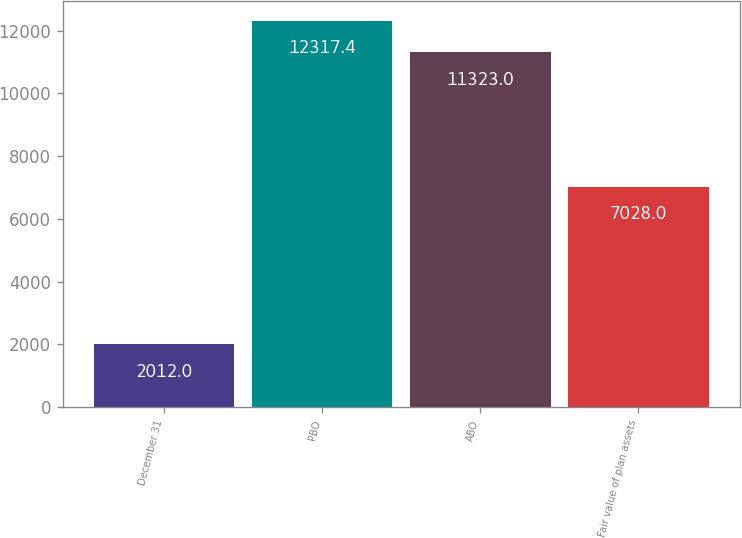Convert chart to OTSL. <chart><loc_0><loc_0><loc_500><loc_500><bar_chart><fcel>December 31<fcel>PBO<fcel>ABO<fcel>Fair value of plan assets<nl><fcel>2012<fcel>12317.4<fcel>11323<fcel>7028<nl></chart> 